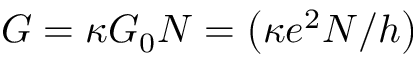Convert formula to latex. <formula><loc_0><loc_0><loc_500><loc_500>G = \kappa G _ { 0 } N = \left ( \kappa e ^ { 2 } N / h \right )</formula> 